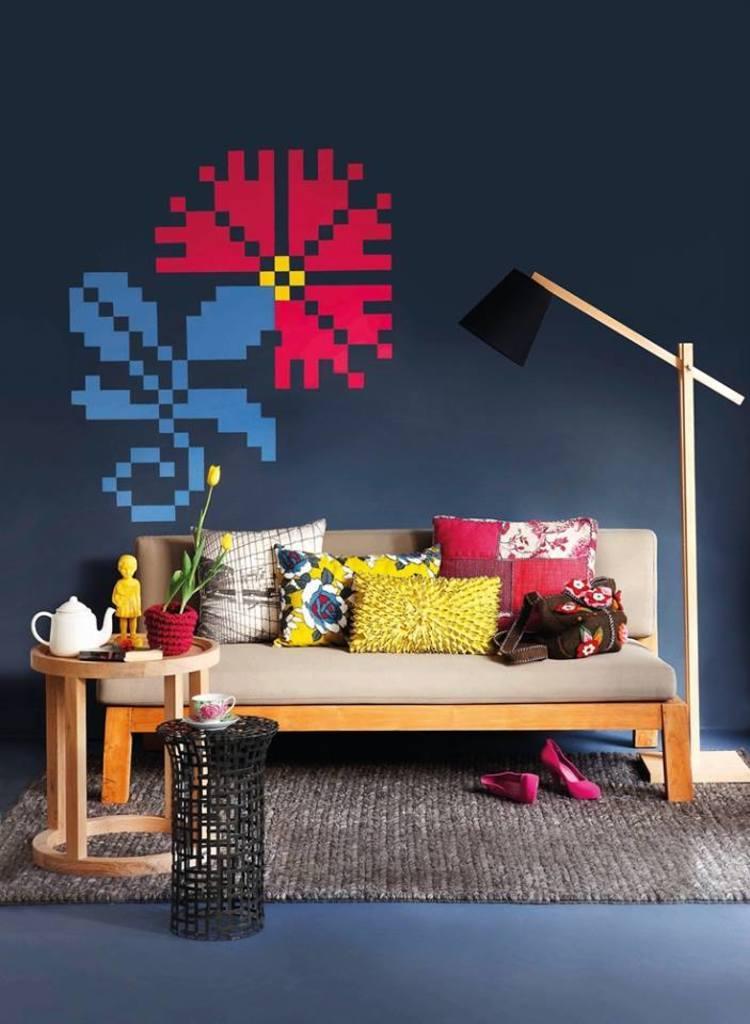Could you give a brief overview of what you see in this image? This image is clicked inside the room. There is a sofa and pillows on the sofas. There is art on the backside of the sofa. the sofa is place in the middle of the room. There is small table like thing and a cup is placed on that table and a table is on the left side bottom and on that table there is a kettle and flower pot tulip flowers. There is doormat in the bottom. There are shoes under the sofa. 